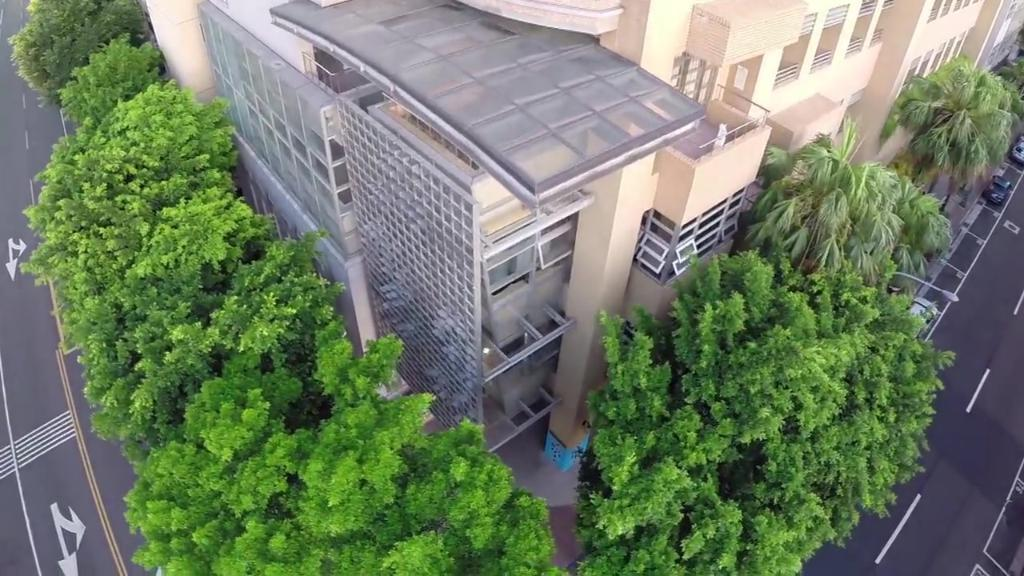What type of structure is visible in the image? There is a building in the image. What natural elements are present around the building? There are trees around the building. What can be seen on the left side of the image? There is a road on the left side of the image. What is visible on the right side of the image? There is a road on the right side of the image. What type of sponge can be seen in the image? There is no sponge present in the image. Can you recite a verse from the image? There is no text or verse present in the image. 